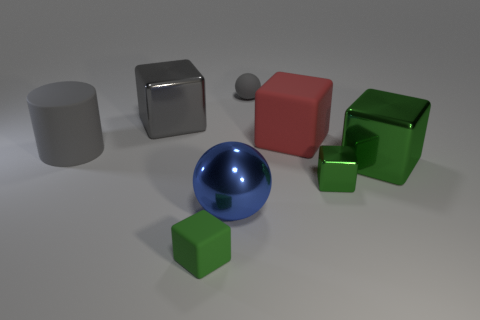Do the tiny gray matte thing and the large blue thing have the same shape?
Provide a succinct answer. Yes. There is a small metallic thing that is the same shape as the large red thing; what is its color?
Offer a terse response. Green. How many other big spheres have the same color as the big metallic sphere?
Your response must be concise. 0. How many things are either rubber objects on the left side of the small rubber cube or tiny things?
Provide a succinct answer. 4. There is a ball that is behind the large cylinder; how big is it?
Your response must be concise. Small. Is the number of big gray rubber cylinders less than the number of tiny green blocks?
Keep it short and to the point. Yes. Is the material of the green cube that is on the left side of the big blue metal thing the same as the small thing behind the large red matte cube?
Your response must be concise. Yes. What shape is the big thing left of the shiny cube to the left of the tiny matte object in front of the big matte cube?
Your answer should be very brief. Cylinder. What number of spheres are the same material as the red cube?
Your response must be concise. 1. How many gray things are on the right side of the big gray cylinder on the left side of the big red cube?
Ensure brevity in your answer.  2. 